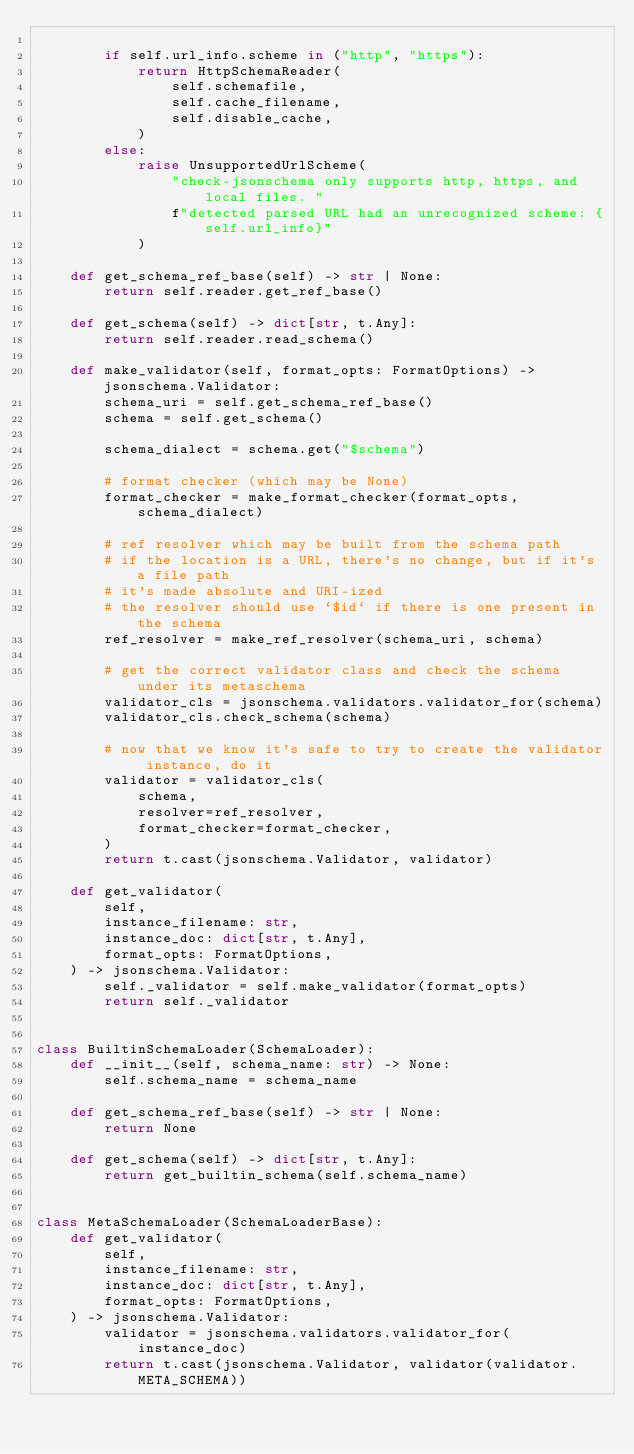<code> <loc_0><loc_0><loc_500><loc_500><_Python_>
        if self.url_info.scheme in ("http", "https"):
            return HttpSchemaReader(
                self.schemafile,
                self.cache_filename,
                self.disable_cache,
            )
        else:
            raise UnsupportedUrlScheme(
                "check-jsonschema only supports http, https, and local files. "
                f"detected parsed URL had an unrecognized scheme: {self.url_info}"
            )

    def get_schema_ref_base(self) -> str | None:
        return self.reader.get_ref_base()

    def get_schema(self) -> dict[str, t.Any]:
        return self.reader.read_schema()

    def make_validator(self, format_opts: FormatOptions) -> jsonschema.Validator:
        schema_uri = self.get_schema_ref_base()
        schema = self.get_schema()

        schema_dialect = schema.get("$schema")

        # format checker (which may be None)
        format_checker = make_format_checker(format_opts, schema_dialect)

        # ref resolver which may be built from the schema path
        # if the location is a URL, there's no change, but if it's a file path
        # it's made absolute and URI-ized
        # the resolver should use `$id` if there is one present in the schema
        ref_resolver = make_ref_resolver(schema_uri, schema)

        # get the correct validator class and check the schema under its metaschema
        validator_cls = jsonschema.validators.validator_for(schema)
        validator_cls.check_schema(schema)

        # now that we know it's safe to try to create the validator instance, do it
        validator = validator_cls(
            schema,
            resolver=ref_resolver,
            format_checker=format_checker,
        )
        return t.cast(jsonschema.Validator, validator)

    def get_validator(
        self,
        instance_filename: str,
        instance_doc: dict[str, t.Any],
        format_opts: FormatOptions,
    ) -> jsonschema.Validator:
        self._validator = self.make_validator(format_opts)
        return self._validator


class BuiltinSchemaLoader(SchemaLoader):
    def __init__(self, schema_name: str) -> None:
        self.schema_name = schema_name

    def get_schema_ref_base(self) -> str | None:
        return None

    def get_schema(self) -> dict[str, t.Any]:
        return get_builtin_schema(self.schema_name)


class MetaSchemaLoader(SchemaLoaderBase):
    def get_validator(
        self,
        instance_filename: str,
        instance_doc: dict[str, t.Any],
        format_opts: FormatOptions,
    ) -> jsonschema.Validator:
        validator = jsonschema.validators.validator_for(instance_doc)
        return t.cast(jsonschema.Validator, validator(validator.META_SCHEMA))
</code> 